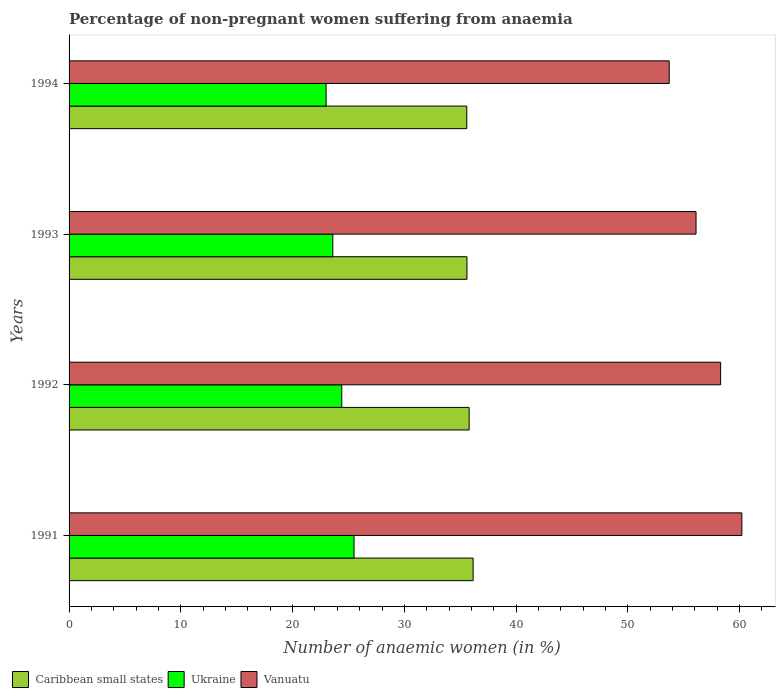How many different coloured bars are there?
Your answer should be very brief. 3. Are the number of bars per tick equal to the number of legend labels?
Your answer should be very brief. Yes. Are the number of bars on each tick of the Y-axis equal?
Make the answer very short. Yes. What is the percentage of non-pregnant women suffering from anaemia in Caribbean small states in 1994?
Provide a short and direct response. 35.59. In which year was the percentage of non-pregnant women suffering from anaemia in Caribbean small states maximum?
Give a very brief answer. 1991. What is the total percentage of non-pregnant women suffering from anaemia in Vanuatu in the graph?
Offer a terse response. 228.3. What is the difference between the percentage of non-pregnant women suffering from anaemia in Ukraine in 1991 and that in 1992?
Your response must be concise. 1.1. What is the difference between the percentage of non-pregnant women suffering from anaemia in Ukraine in 1993 and the percentage of non-pregnant women suffering from anaemia in Caribbean small states in 1991?
Ensure brevity in your answer.  -12.55. What is the average percentage of non-pregnant women suffering from anaemia in Caribbean small states per year?
Make the answer very short. 35.78. In the year 1993, what is the difference between the percentage of non-pregnant women suffering from anaemia in Caribbean small states and percentage of non-pregnant women suffering from anaemia in Vanuatu?
Give a very brief answer. -20.5. In how many years, is the percentage of non-pregnant women suffering from anaemia in Vanuatu greater than 10 %?
Provide a succinct answer. 4. What is the ratio of the percentage of non-pregnant women suffering from anaemia in Ukraine in 1992 to that in 1994?
Your response must be concise. 1.06. Is the difference between the percentage of non-pregnant women suffering from anaemia in Caribbean small states in 1992 and 1993 greater than the difference between the percentage of non-pregnant women suffering from anaemia in Vanuatu in 1992 and 1993?
Provide a succinct answer. No. What is the difference between the highest and the second highest percentage of non-pregnant women suffering from anaemia in Caribbean small states?
Offer a very short reply. 0.36. Is the sum of the percentage of non-pregnant women suffering from anaemia in Ukraine in 1993 and 1994 greater than the maximum percentage of non-pregnant women suffering from anaemia in Caribbean small states across all years?
Make the answer very short. Yes. What does the 2nd bar from the top in 1992 represents?
Offer a terse response. Ukraine. What does the 3rd bar from the bottom in 1993 represents?
Your answer should be compact. Vanuatu. Is it the case that in every year, the sum of the percentage of non-pregnant women suffering from anaemia in Ukraine and percentage of non-pregnant women suffering from anaemia in Caribbean small states is greater than the percentage of non-pregnant women suffering from anaemia in Vanuatu?
Provide a short and direct response. Yes. How many bars are there?
Ensure brevity in your answer.  12. Are all the bars in the graph horizontal?
Offer a terse response. Yes. How many years are there in the graph?
Provide a succinct answer. 4. What is the difference between two consecutive major ticks on the X-axis?
Provide a succinct answer. 10. Does the graph contain any zero values?
Ensure brevity in your answer.  No. How many legend labels are there?
Provide a short and direct response. 3. How are the legend labels stacked?
Provide a succinct answer. Horizontal. What is the title of the graph?
Your answer should be very brief. Percentage of non-pregnant women suffering from anaemia. What is the label or title of the X-axis?
Make the answer very short. Number of anaemic women (in %). What is the label or title of the Y-axis?
Keep it short and to the point. Years. What is the Number of anaemic women (in %) of Caribbean small states in 1991?
Offer a very short reply. 36.15. What is the Number of anaemic women (in %) in Vanuatu in 1991?
Offer a very short reply. 60.2. What is the Number of anaemic women (in %) in Caribbean small states in 1992?
Give a very brief answer. 35.8. What is the Number of anaemic women (in %) in Ukraine in 1992?
Provide a succinct answer. 24.4. What is the Number of anaemic women (in %) in Vanuatu in 1992?
Your response must be concise. 58.3. What is the Number of anaemic women (in %) of Caribbean small states in 1993?
Your answer should be very brief. 35.6. What is the Number of anaemic women (in %) in Ukraine in 1993?
Offer a terse response. 23.6. What is the Number of anaemic women (in %) of Vanuatu in 1993?
Provide a succinct answer. 56.1. What is the Number of anaemic women (in %) in Caribbean small states in 1994?
Keep it short and to the point. 35.59. What is the Number of anaemic women (in %) of Ukraine in 1994?
Your answer should be compact. 23. What is the Number of anaemic women (in %) in Vanuatu in 1994?
Your answer should be very brief. 53.7. Across all years, what is the maximum Number of anaemic women (in %) of Caribbean small states?
Provide a succinct answer. 36.15. Across all years, what is the maximum Number of anaemic women (in %) in Vanuatu?
Your answer should be compact. 60.2. Across all years, what is the minimum Number of anaemic women (in %) of Caribbean small states?
Give a very brief answer. 35.59. Across all years, what is the minimum Number of anaemic women (in %) in Vanuatu?
Your answer should be very brief. 53.7. What is the total Number of anaemic women (in %) in Caribbean small states in the graph?
Make the answer very short. 143.14. What is the total Number of anaemic women (in %) in Ukraine in the graph?
Your response must be concise. 96.5. What is the total Number of anaemic women (in %) in Vanuatu in the graph?
Keep it short and to the point. 228.3. What is the difference between the Number of anaemic women (in %) of Caribbean small states in 1991 and that in 1992?
Provide a succinct answer. 0.36. What is the difference between the Number of anaemic women (in %) in Caribbean small states in 1991 and that in 1993?
Keep it short and to the point. 0.55. What is the difference between the Number of anaemic women (in %) of Ukraine in 1991 and that in 1993?
Your answer should be very brief. 1.9. What is the difference between the Number of anaemic women (in %) in Caribbean small states in 1991 and that in 1994?
Provide a succinct answer. 0.57. What is the difference between the Number of anaemic women (in %) of Vanuatu in 1991 and that in 1994?
Keep it short and to the point. 6.5. What is the difference between the Number of anaemic women (in %) of Caribbean small states in 1992 and that in 1993?
Your answer should be very brief. 0.19. What is the difference between the Number of anaemic women (in %) of Ukraine in 1992 and that in 1993?
Your answer should be compact. 0.8. What is the difference between the Number of anaemic women (in %) of Caribbean small states in 1992 and that in 1994?
Your response must be concise. 0.21. What is the difference between the Number of anaemic women (in %) of Caribbean small states in 1993 and that in 1994?
Provide a short and direct response. 0.02. What is the difference between the Number of anaemic women (in %) in Ukraine in 1993 and that in 1994?
Offer a very short reply. 0.6. What is the difference between the Number of anaemic women (in %) of Caribbean small states in 1991 and the Number of anaemic women (in %) of Ukraine in 1992?
Provide a short and direct response. 11.75. What is the difference between the Number of anaemic women (in %) in Caribbean small states in 1991 and the Number of anaemic women (in %) in Vanuatu in 1992?
Your response must be concise. -22.15. What is the difference between the Number of anaemic women (in %) in Ukraine in 1991 and the Number of anaemic women (in %) in Vanuatu in 1992?
Offer a terse response. -32.8. What is the difference between the Number of anaemic women (in %) of Caribbean small states in 1991 and the Number of anaemic women (in %) of Ukraine in 1993?
Provide a short and direct response. 12.55. What is the difference between the Number of anaemic women (in %) in Caribbean small states in 1991 and the Number of anaemic women (in %) in Vanuatu in 1993?
Offer a very short reply. -19.95. What is the difference between the Number of anaemic women (in %) in Ukraine in 1991 and the Number of anaemic women (in %) in Vanuatu in 1993?
Your answer should be very brief. -30.6. What is the difference between the Number of anaemic women (in %) of Caribbean small states in 1991 and the Number of anaemic women (in %) of Ukraine in 1994?
Offer a terse response. 13.15. What is the difference between the Number of anaemic women (in %) in Caribbean small states in 1991 and the Number of anaemic women (in %) in Vanuatu in 1994?
Offer a terse response. -17.55. What is the difference between the Number of anaemic women (in %) in Ukraine in 1991 and the Number of anaemic women (in %) in Vanuatu in 1994?
Give a very brief answer. -28.2. What is the difference between the Number of anaemic women (in %) in Caribbean small states in 1992 and the Number of anaemic women (in %) in Ukraine in 1993?
Your response must be concise. 12.2. What is the difference between the Number of anaemic women (in %) of Caribbean small states in 1992 and the Number of anaemic women (in %) of Vanuatu in 1993?
Provide a short and direct response. -20.3. What is the difference between the Number of anaemic women (in %) of Ukraine in 1992 and the Number of anaemic women (in %) of Vanuatu in 1993?
Your answer should be compact. -31.7. What is the difference between the Number of anaemic women (in %) in Caribbean small states in 1992 and the Number of anaemic women (in %) in Ukraine in 1994?
Give a very brief answer. 12.8. What is the difference between the Number of anaemic women (in %) of Caribbean small states in 1992 and the Number of anaemic women (in %) of Vanuatu in 1994?
Ensure brevity in your answer.  -17.9. What is the difference between the Number of anaemic women (in %) of Ukraine in 1992 and the Number of anaemic women (in %) of Vanuatu in 1994?
Give a very brief answer. -29.3. What is the difference between the Number of anaemic women (in %) in Caribbean small states in 1993 and the Number of anaemic women (in %) in Ukraine in 1994?
Offer a terse response. 12.6. What is the difference between the Number of anaemic women (in %) of Caribbean small states in 1993 and the Number of anaemic women (in %) of Vanuatu in 1994?
Give a very brief answer. -18.1. What is the difference between the Number of anaemic women (in %) in Ukraine in 1993 and the Number of anaemic women (in %) in Vanuatu in 1994?
Provide a short and direct response. -30.1. What is the average Number of anaemic women (in %) in Caribbean small states per year?
Ensure brevity in your answer.  35.78. What is the average Number of anaemic women (in %) in Ukraine per year?
Make the answer very short. 24.12. What is the average Number of anaemic women (in %) of Vanuatu per year?
Provide a succinct answer. 57.08. In the year 1991, what is the difference between the Number of anaemic women (in %) of Caribbean small states and Number of anaemic women (in %) of Ukraine?
Your response must be concise. 10.65. In the year 1991, what is the difference between the Number of anaemic women (in %) of Caribbean small states and Number of anaemic women (in %) of Vanuatu?
Provide a succinct answer. -24.05. In the year 1991, what is the difference between the Number of anaemic women (in %) of Ukraine and Number of anaemic women (in %) of Vanuatu?
Your answer should be compact. -34.7. In the year 1992, what is the difference between the Number of anaemic women (in %) of Caribbean small states and Number of anaemic women (in %) of Ukraine?
Provide a short and direct response. 11.4. In the year 1992, what is the difference between the Number of anaemic women (in %) in Caribbean small states and Number of anaemic women (in %) in Vanuatu?
Give a very brief answer. -22.5. In the year 1992, what is the difference between the Number of anaemic women (in %) of Ukraine and Number of anaemic women (in %) of Vanuatu?
Your answer should be compact. -33.9. In the year 1993, what is the difference between the Number of anaemic women (in %) of Caribbean small states and Number of anaemic women (in %) of Ukraine?
Offer a very short reply. 12. In the year 1993, what is the difference between the Number of anaemic women (in %) of Caribbean small states and Number of anaemic women (in %) of Vanuatu?
Offer a terse response. -20.5. In the year 1993, what is the difference between the Number of anaemic women (in %) in Ukraine and Number of anaemic women (in %) in Vanuatu?
Provide a short and direct response. -32.5. In the year 1994, what is the difference between the Number of anaemic women (in %) in Caribbean small states and Number of anaemic women (in %) in Ukraine?
Give a very brief answer. 12.59. In the year 1994, what is the difference between the Number of anaemic women (in %) of Caribbean small states and Number of anaemic women (in %) of Vanuatu?
Make the answer very short. -18.11. In the year 1994, what is the difference between the Number of anaemic women (in %) in Ukraine and Number of anaemic women (in %) in Vanuatu?
Your answer should be compact. -30.7. What is the ratio of the Number of anaemic women (in %) in Ukraine in 1991 to that in 1992?
Provide a short and direct response. 1.05. What is the ratio of the Number of anaemic women (in %) in Vanuatu in 1991 to that in 1992?
Your answer should be very brief. 1.03. What is the ratio of the Number of anaemic women (in %) of Caribbean small states in 1991 to that in 1993?
Offer a very short reply. 1.02. What is the ratio of the Number of anaemic women (in %) in Ukraine in 1991 to that in 1993?
Keep it short and to the point. 1.08. What is the ratio of the Number of anaemic women (in %) of Vanuatu in 1991 to that in 1993?
Offer a very short reply. 1.07. What is the ratio of the Number of anaemic women (in %) of Caribbean small states in 1991 to that in 1994?
Ensure brevity in your answer.  1.02. What is the ratio of the Number of anaemic women (in %) of Ukraine in 1991 to that in 1994?
Provide a short and direct response. 1.11. What is the ratio of the Number of anaemic women (in %) in Vanuatu in 1991 to that in 1994?
Provide a succinct answer. 1.12. What is the ratio of the Number of anaemic women (in %) in Caribbean small states in 1992 to that in 1993?
Your answer should be very brief. 1.01. What is the ratio of the Number of anaemic women (in %) in Ukraine in 1992 to that in 1993?
Your response must be concise. 1.03. What is the ratio of the Number of anaemic women (in %) in Vanuatu in 1992 to that in 1993?
Offer a very short reply. 1.04. What is the ratio of the Number of anaemic women (in %) in Ukraine in 1992 to that in 1994?
Provide a short and direct response. 1.06. What is the ratio of the Number of anaemic women (in %) of Vanuatu in 1992 to that in 1994?
Offer a very short reply. 1.09. What is the ratio of the Number of anaemic women (in %) of Caribbean small states in 1993 to that in 1994?
Keep it short and to the point. 1. What is the ratio of the Number of anaemic women (in %) of Ukraine in 1993 to that in 1994?
Offer a terse response. 1.03. What is the ratio of the Number of anaemic women (in %) in Vanuatu in 1993 to that in 1994?
Provide a short and direct response. 1.04. What is the difference between the highest and the second highest Number of anaemic women (in %) in Caribbean small states?
Provide a short and direct response. 0.36. What is the difference between the highest and the second highest Number of anaemic women (in %) in Ukraine?
Ensure brevity in your answer.  1.1. What is the difference between the highest and the lowest Number of anaemic women (in %) in Caribbean small states?
Your response must be concise. 0.57. What is the difference between the highest and the lowest Number of anaemic women (in %) of Ukraine?
Your answer should be compact. 2.5. What is the difference between the highest and the lowest Number of anaemic women (in %) of Vanuatu?
Give a very brief answer. 6.5. 